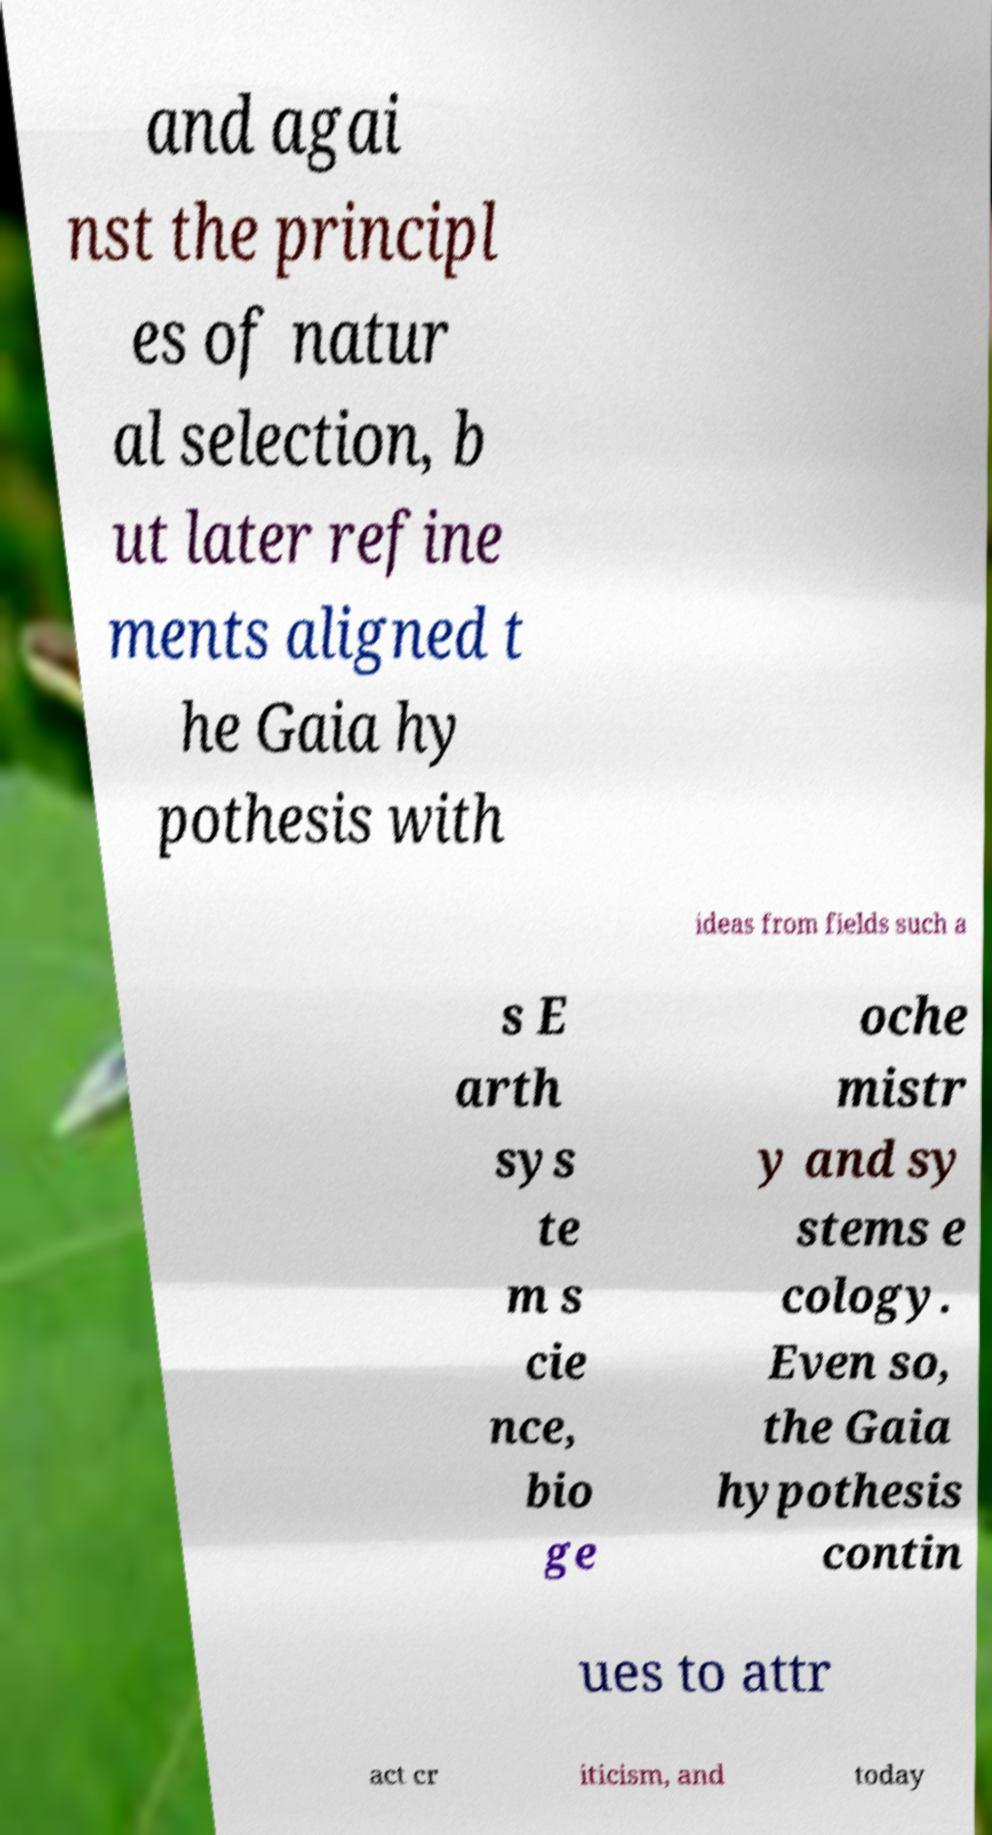For documentation purposes, I need the text within this image transcribed. Could you provide that? and agai nst the principl es of natur al selection, b ut later refine ments aligned t he Gaia hy pothesis with ideas from fields such a s E arth sys te m s cie nce, bio ge oche mistr y and sy stems e cology. Even so, the Gaia hypothesis contin ues to attr act cr iticism, and today 